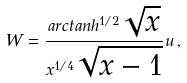Convert formula to latex. <formula><loc_0><loc_0><loc_500><loc_500>W = \frac { a r c t a n h ^ { 1 / 2 } \sqrt { x } } { x ^ { 1 / 4 } \sqrt { x - 1 } } u \, ,</formula> 